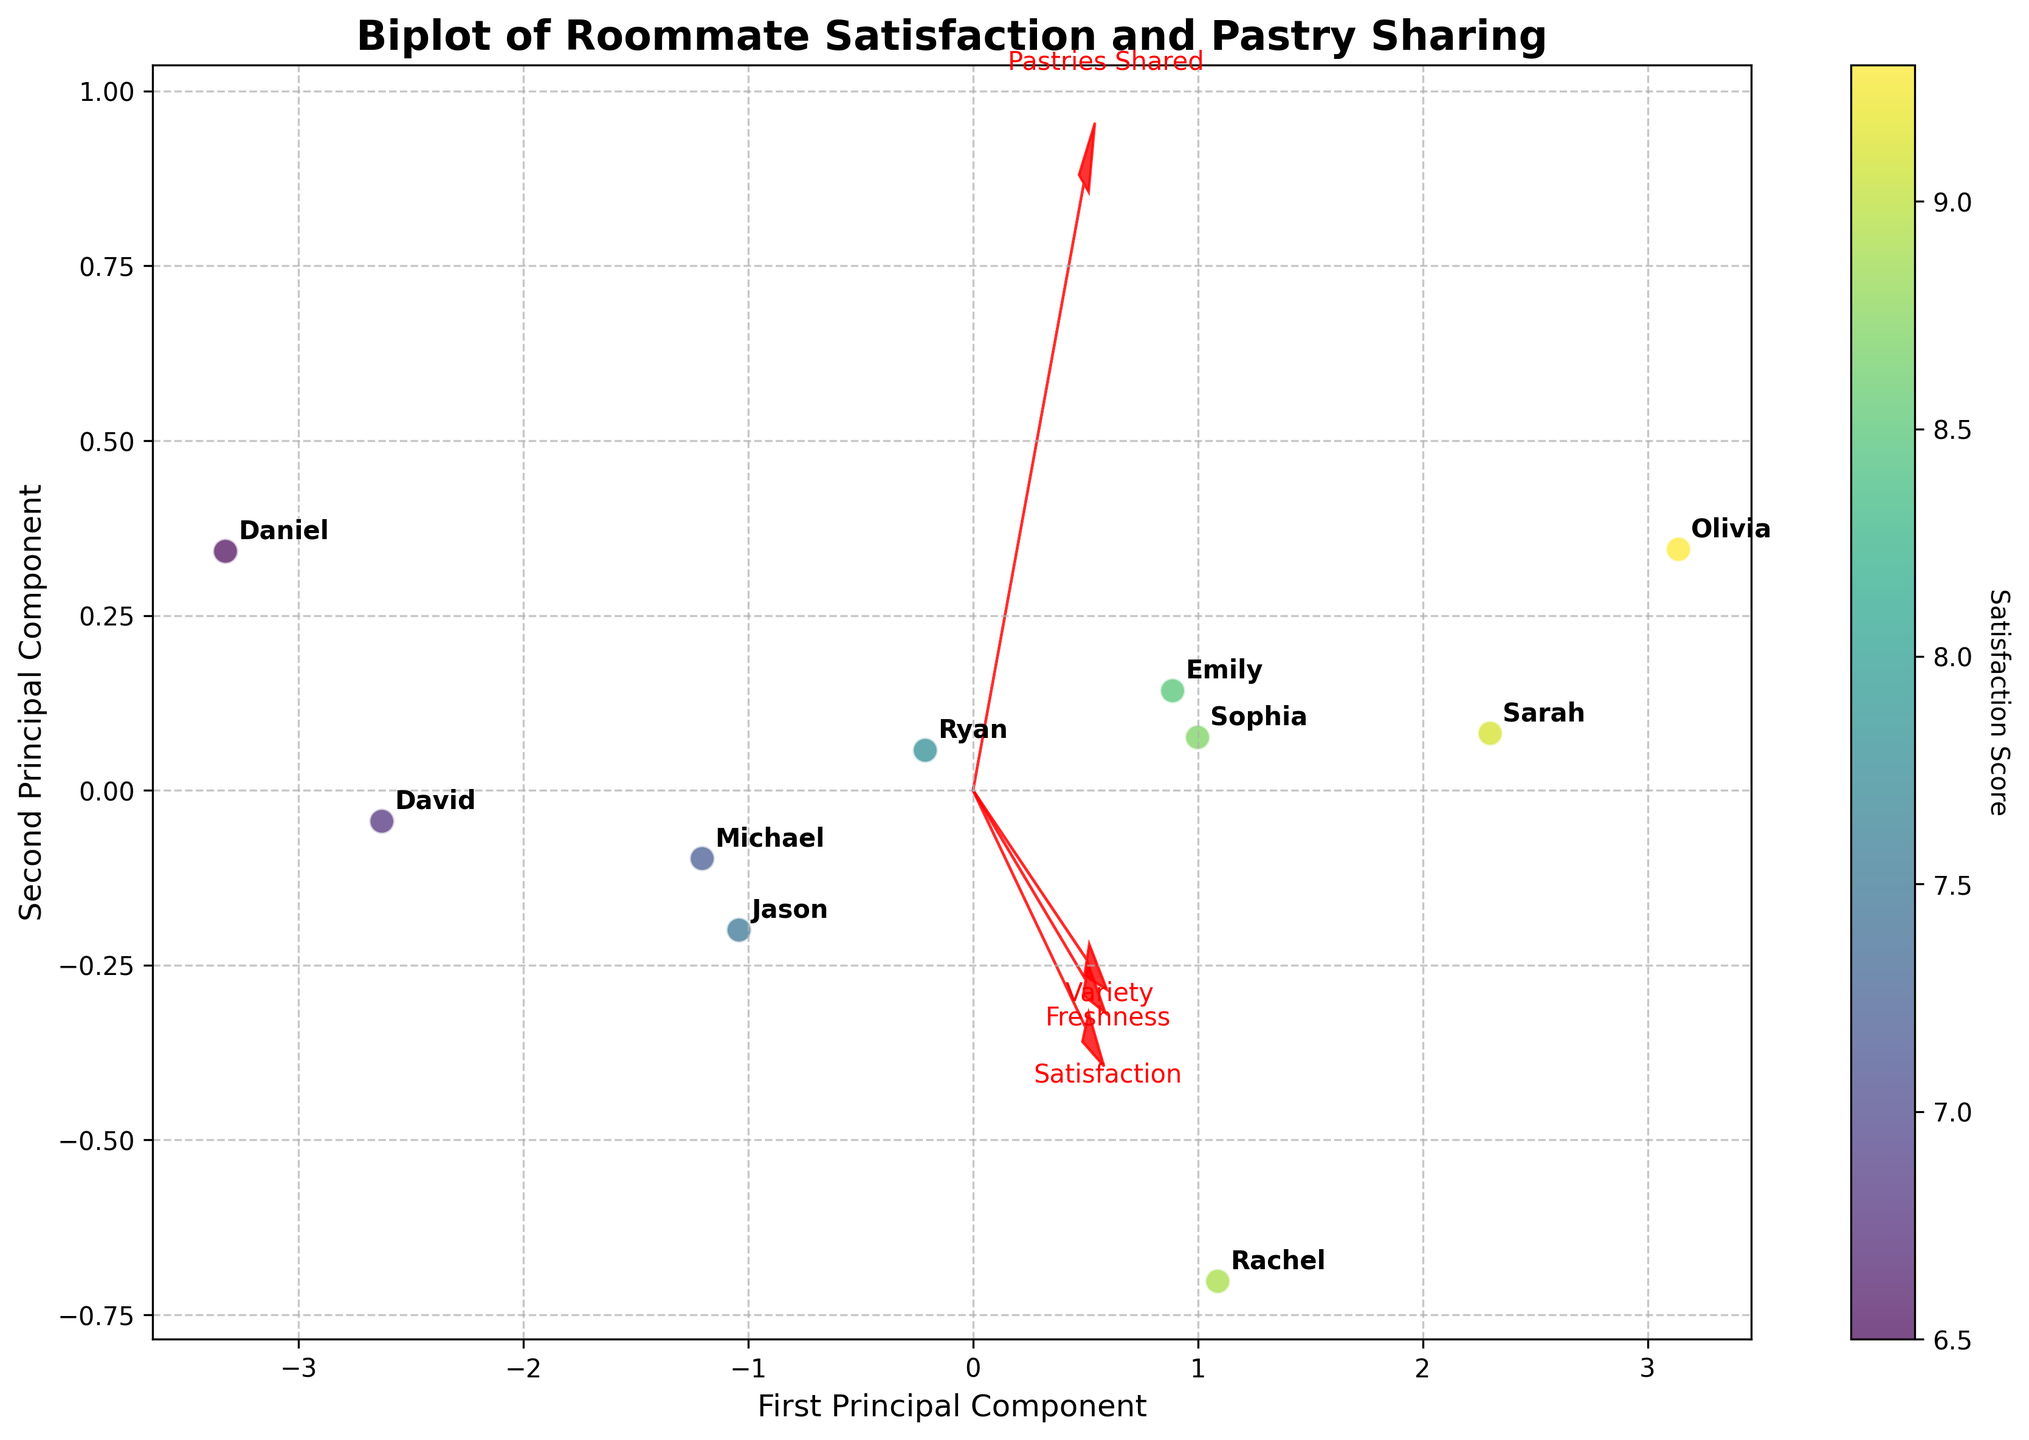What is the title of the plot? The title is usually located at the top of the figure and is a key element that describes what the plot is about. In this case, it is mentioned in the code as "Biplot of Roommate Satisfaction and Pastry Sharing."
Answer: Biplot of Roommate Satisfaction and Pastry Sharing How many data points are there in the figure? By counting the number of unique names labeled on the Biplot, we can determine the number of data points. There are ten names (Emily, Michael, Sarah, David, Rachel, Jason, Olivia, Daniel, Sophia, Ryan) mentioned in the data.
Answer: 10 Which roommate has the highest satisfaction score according to the color scale? The color scale on the plot indicates satisfaction scores, with darker (or more intense) colors typically representing higher scores. Olivia is indicated to have the highest satisfaction score with a score of 9.3.
Answer: Olivia What are the labels of the axes? The axes labels are located near the horizontal and vertical lines in the plot. The code indicates the labels are "First Principal Component" for the x-axis and "Second Principal Component" for the y-axis.
Answer: First Principal Component, Second Principal Component Which feature vector has the highest value on the first principal component? Feature vectors are shown by arrows, and their values on the principal components can be determined by the length and direction of the arrows. The feature labeled "Freshness" has the highest value on the first principal component by examining the arrow pointing furthest along the x-axis.
Answer: Freshness What is the relationship between Pastries Shared per Week and Satisfaction Score? To determine this, we examine the direction and length of the arrows corresponding to these features on the biplot. Both arrows generally point in the same direction, suggesting a positive relationship. When a roommate shares more pastries, their satisfaction score tends to be higher.
Answer: Positive relationship Which two roommates share the same frequency of pastries but have different satisfaction scores? By comparing the positions of the data points (labeled with names) along the dimension that captures "Pastries Shared per Week", we notice that Michael and Jason both share pastries twice a week, but Michael has a satisfaction score of 7.2 whereas Jason has a score of 7.5.
Answer: Michael and Jason On average, how many pastries per week do roommates with a satisfaction score above 8 share? First, identify the roommates with satisfaction scores above 8 (Emily, Sarah, Rachel, Olivia, Sophia). Then add their "Pastries_Shared_Per_Week" values (4, 5, 3, 6, 4) and divide by the number of qualifying roommates, which is 5. The sum is 22, so the average is 22/5 = 4.4.
Answer: 4.4 Which feature has the lowest value on the first principal component? By examining the position and orientation of the arrows on the biplot, the feature labeled "Variety" has the shortest projection along the x-axis, indicating it has the lowest value on the first principal component.
Answer: Variety 